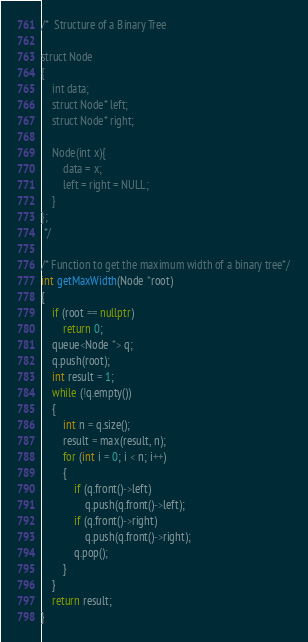Convert code to text. <code><loc_0><loc_0><loc_500><loc_500><_C++_>/*  Structure of a Binary Tree 

struct Node
{
    int data;
    struct Node* left;
    struct Node* right;
    
    Node(int x){
        data = x;
        left = right = NULL;
    }
};
 */

/* Function to get the maximum width of a binary tree*/
int getMaxWidth(Node *root)
{
    if (root == nullptr)
        return 0;
    queue<Node *> q;
    q.push(root);
    int result = 1;
    while (!q.empty())
    {
        int n = q.size();
        result = max(result, n);
        for (int i = 0; i < n; i++)
        {
            if (q.front()->left)
                q.push(q.front()->left);
            if (q.front()->right)
                q.push(q.front()->right);
            q.pop();
        }
    }
    return result;
}</code> 